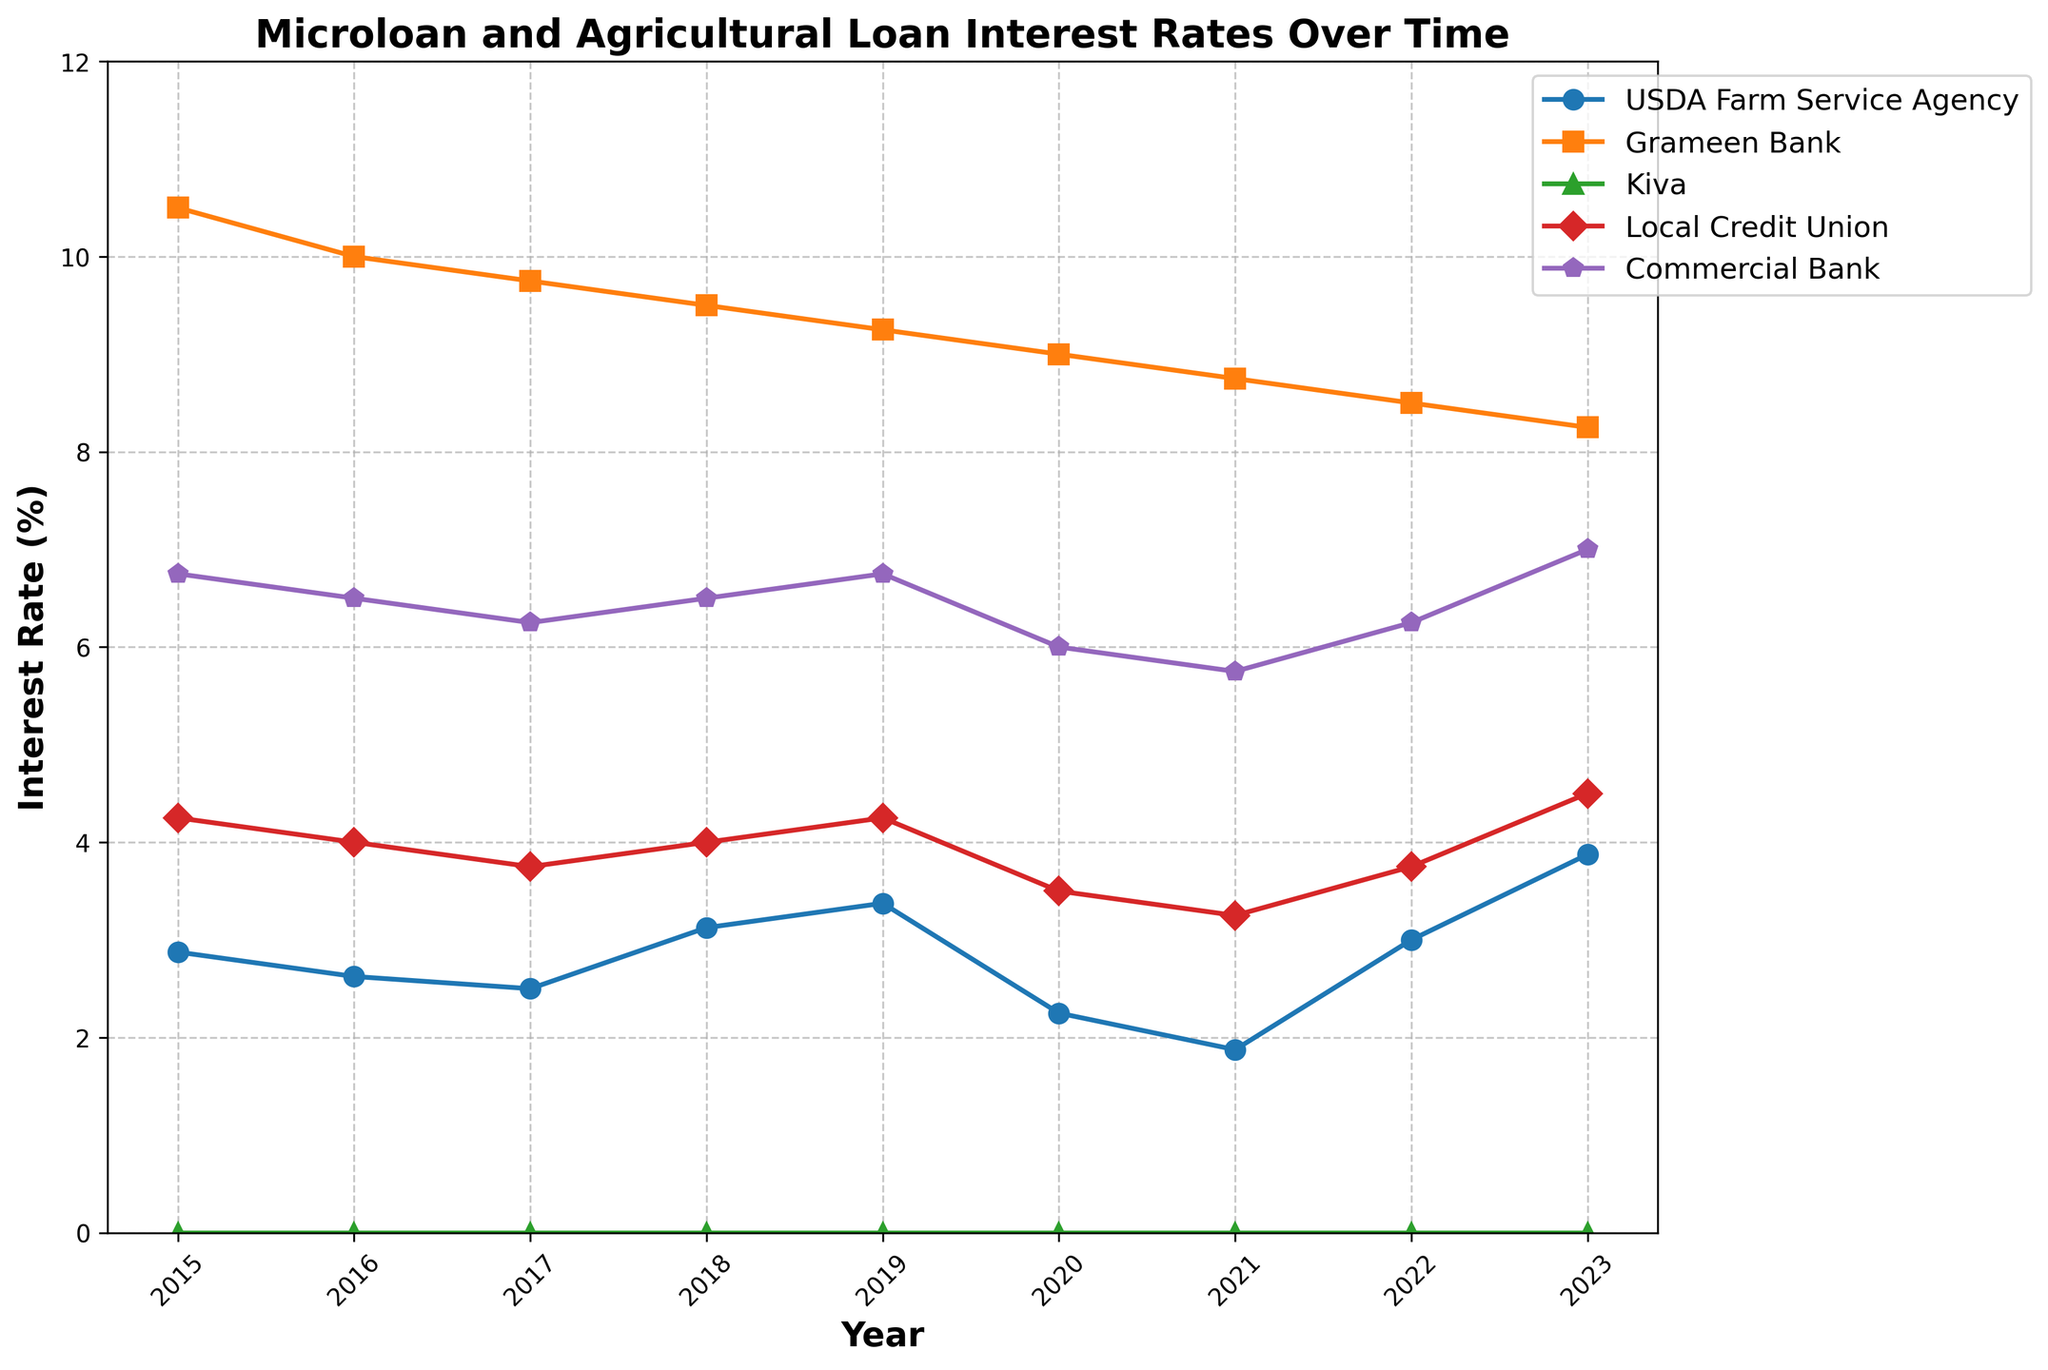What is the lowest interest rate provided by the USDA Farm Service Agency over the years? Look for the minimum value in the USDA Farm Service Agency line. The lowest value is 1.875% in 2021.
Answer: 1.875% Between the USDA Farm Service Agency and the Grameen Bank, which had higher interest rates in 2017? Compare the values for the USDA Farm Service Agency and Grameen Bank in 2017. The rates are 2.5% for the USDA Farm Service Agency and 9.75% for Grameen Bank.
Answer: Grameen Bank In which year did the Grameen Bank's interest rate drop by 0.75% from the previous year? Check year-by-year changes for Grameen Bank. Between 2015 and 2016, it dropped from 10.5% to 10%, a 0.5% drop; between 2016 and 2017, it dropped from 10% to 9.75%, a 0.25% drop; between 2017 and 2018, it dropped from 9.75% to 9.5%, a 0.25% drop; between 2018 and 2019, it dropped from 9.5% to 9.25%, a 0.25% drop; between 2019 and 2020, it dropped from 9.25% to 9%, a 0.25% drop; between 2021 and 2022, it dropped from 8.75% to 8.5%, a 0.25% drop; between 2022 and 2023, it dropped from 8.5% to 8.25%, a 0.25% drop. None of the above meets the condition. Correct answer should be None.
Answer: None Which lender had the most stable interest rate over the years? Look for the line with the least variation. Kiva's interest rate is 0% across all years, indicating stability.
Answer: Kiva By how much did the interest rate of the Local Credit Union change from 2015 to 2023? Subtract the interest rate of the Local Credit Union in 2015 (4.25%) from that in 2023 (4.5%). The change is 4.5% - 4.25% = 0.25%.
Answer: 0.25% Which year saw the highest interest rate for Commercial Bank and what was the rate? Locate the peak of the Commercial Bank line. In 2015 and 2019, the rate was highest at 6.75%.
Answer: 2015 and 2019, 6.75% If you average out the interest rates of the USDA Farm Service Agency over the years, what would be the result? Sum all interest rates of USDA Farm Service Agency from 2015 to 2023 and divide by the number of years: (2.875% + 2.625% + 2.5% + 3.125% + 3.375% + 2.25% + 1.875% + 3.0% + 3.875%)/9. The sum is 25.625%. Divide by 9 to get approximately 2.847%.
Answer: 2.847% In 2023, which lender had the lowest interest rate and what was it? Check the values for all lenders in 2023. Kiva remains at 0%, the lowest rate.
Answer: Kiva, 0% 